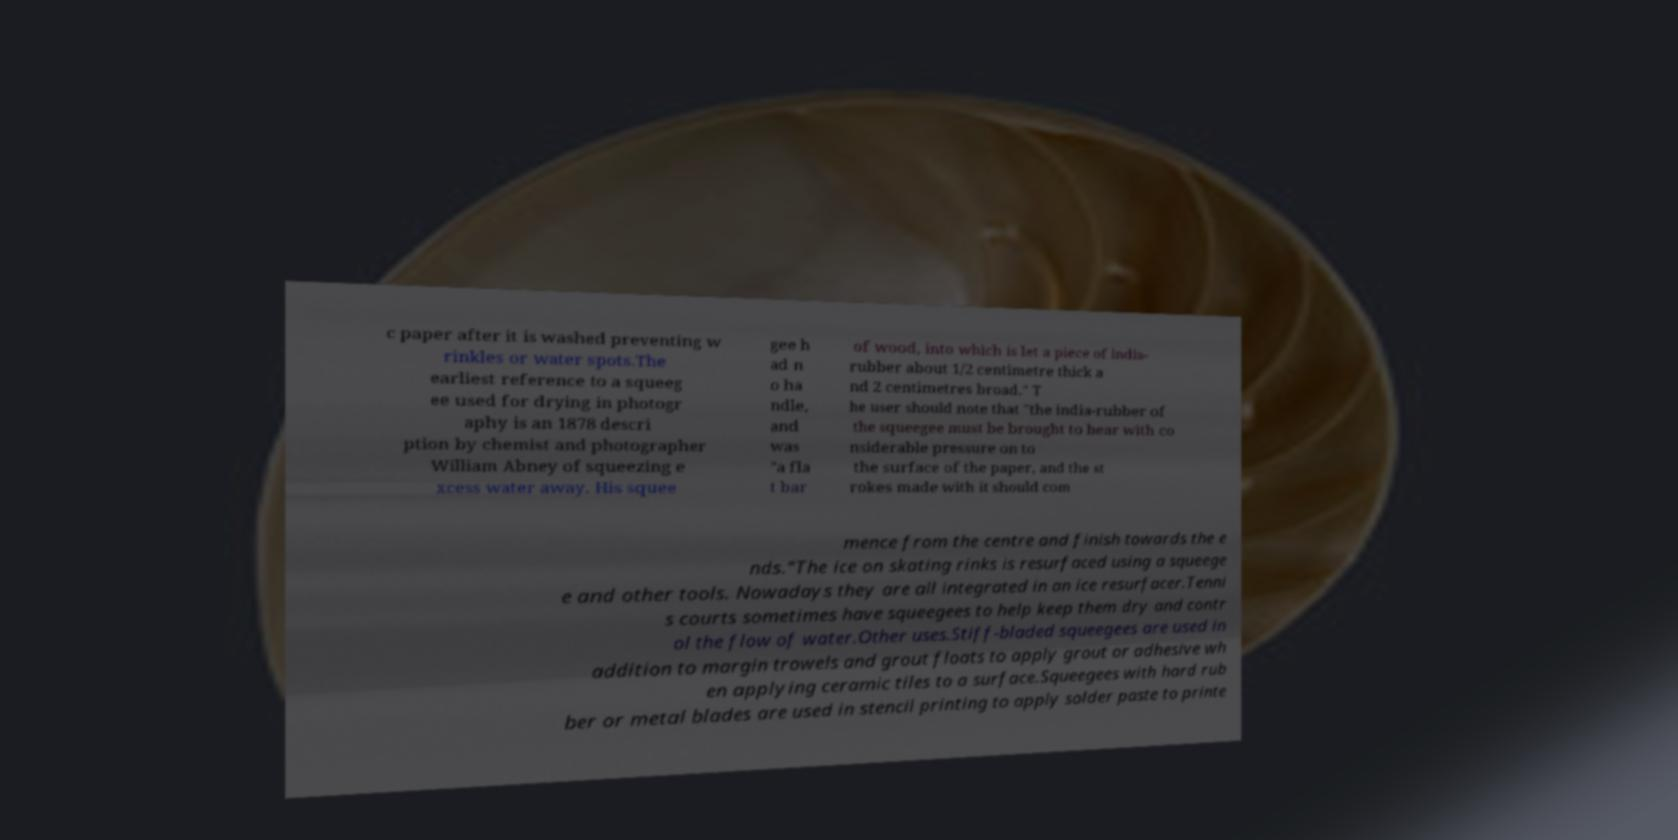I need the written content from this picture converted into text. Can you do that? c paper after it is washed preventing w rinkles or water spots.The earliest reference to a squeeg ee used for drying in photogr aphy is an 1878 descri ption by chemist and photographer William Abney of squeezing e xcess water away. His squee gee h ad n o ha ndle, and was "a fla t bar of wood, into which is let a piece of india- rubber about 1/2 centimetre thick a nd 2 centimetres broad." T he user should note that "the india-rubber of the squeegee must be brought to bear with co nsiderable pressure on to the surface of the paper, and the st rokes made with it should com mence from the centre and finish towards the e nds."The ice on skating rinks is resurfaced using a squeege e and other tools. Nowadays they are all integrated in an ice resurfacer.Tenni s courts sometimes have squeegees to help keep them dry and contr ol the flow of water.Other uses.Stiff-bladed squeegees are used in addition to margin trowels and grout floats to apply grout or adhesive wh en applying ceramic tiles to a surface.Squeegees with hard rub ber or metal blades are used in stencil printing to apply solder paste to printe 